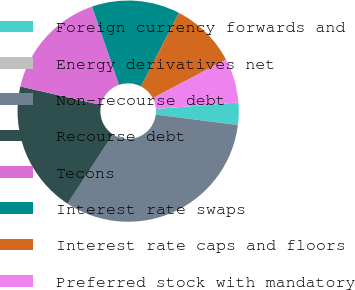<chart> <loc_0><loc_0><loc_500><loc_500><pie_chart><fcel>Foreign currency forwards and<fcel>Energy derivatives net<fcel>Non-recourse debt<fcel>Recourse debt<fcel>Tecons<fcel>Interest rate swaps<fcel>Interest rate caps and floors<fcel>Preferred stock with mandatory<nl><fcel>3.24%<fcel>0.01%<fcel>32.24%<fcel>19.35%<fcel>16.13%<fcel>12.9%<fcel>9.68%<fcel>6.46%<nl></chart> 